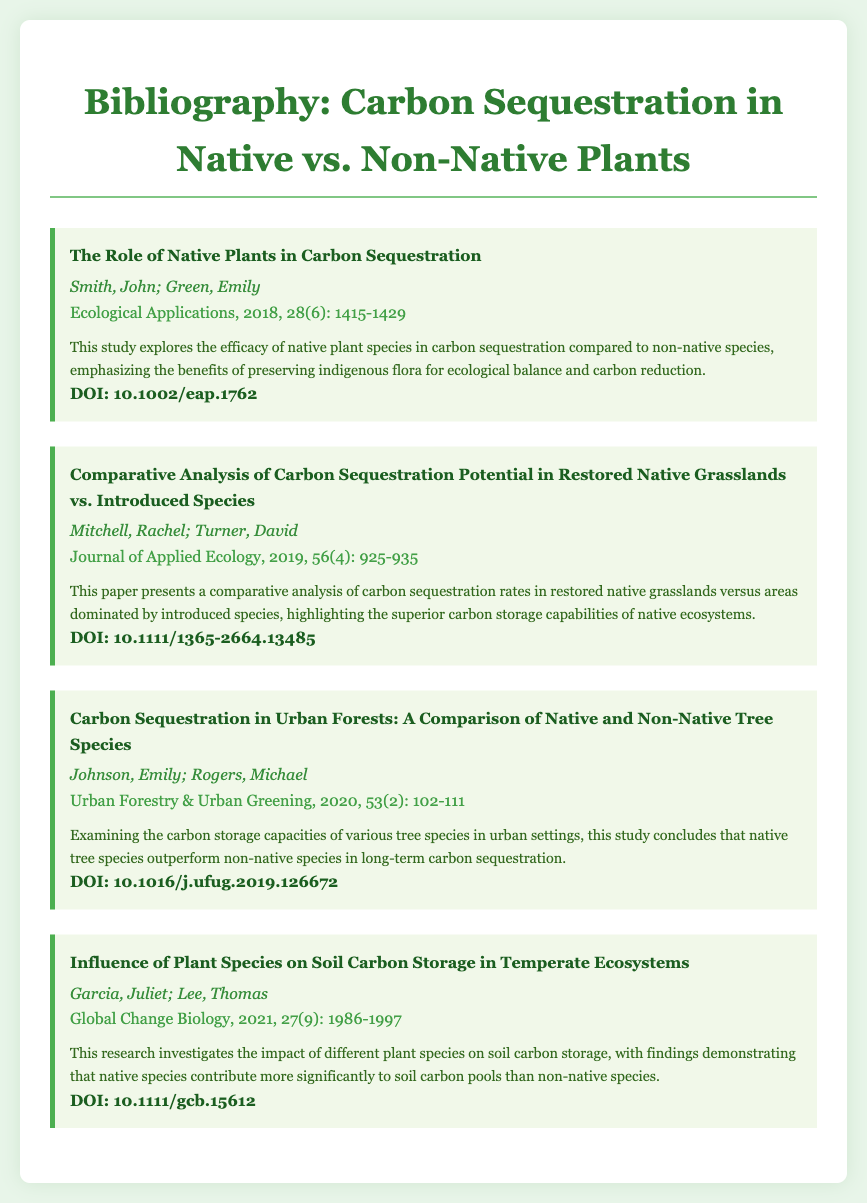what is the title of the first entry? The title is specified in the first entry of the document, which is "The Role of Native Plants in Carbon Sequestration."
Answer: The Role of Native Plants in Carbon Sequestration who are the authors of the second entry? The second entry lists "Mitchell, Rachel; Turner, David" as the authors.
Answer: Mitchell, Rachel; Turner, David what year was the article about urban forests published? The publication year is provided in the journal reference of the entry focused on urban forests, which is 2020.
Answer: 2020 which journal published the research on soil carbon storage? The document indicates that the research on soil carbon storage was published in "Global Change Biology."
Answer: Global Change Biology which entry highlights the superior carbon storage capabilities of native ecosystems? The description of the second entry mentions the superior carbon storage capabilities of native ecosystems.
Answer: Comparative Analysis of Carbon Sequestration Potential in Restored Native Grasslands vs. Introduced Species how many entries are included in the bibliography? The document lists a total of four distinct entries in the bibliography.
Answer: 4 what is the DOI of the last entry? The DOI for the last entry is clearly stated in the document as "10.1111/gcb.15612."
Answer: 10.1111/gcb.15612 what is the main finding of the third entry? The main finding is summarized in the abstract, which states that native tree species outperform non-native species in carbon sequestration.
Answer: Native tree species outperform non-native species in carbon sequestration 